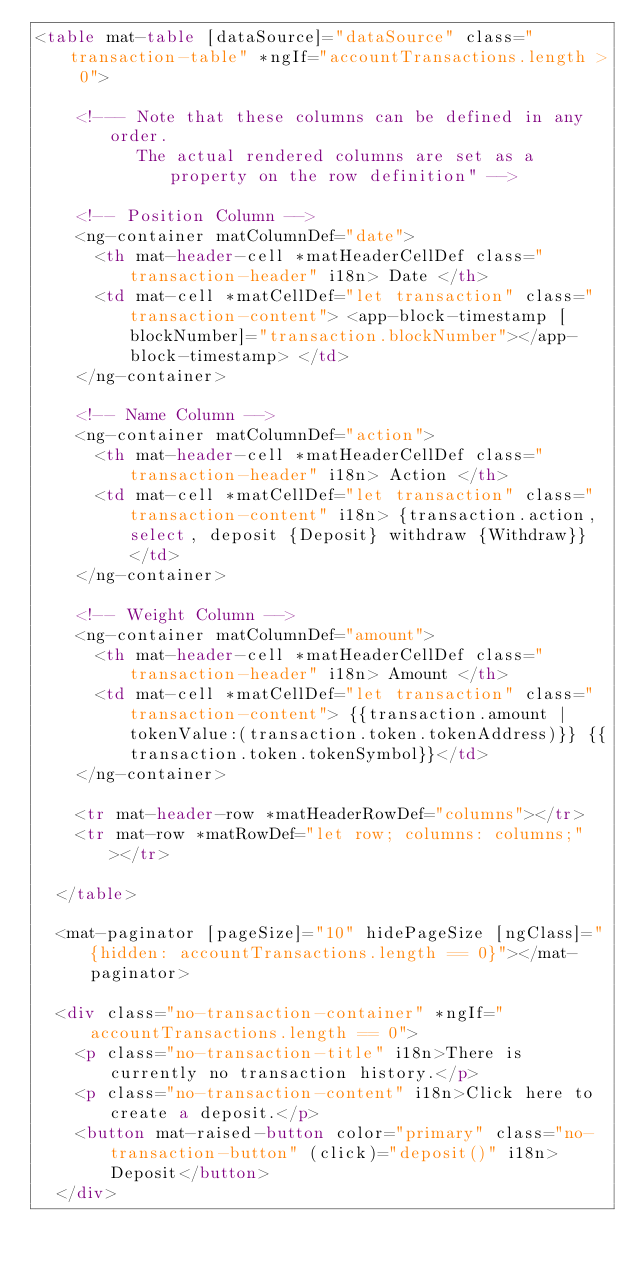<code> <loc_0><loc_0><loc_500><loc_500><_HTML_><table mat-table [dataSource]="dataSource" class="transaction-table" *ngIf="accountTransactions.length > 0">

    <!--- Note that these columns can be defined in any order.
          The actual rendered columns are set as a property on the row definition" -->
  
    <!-- Position Column -->
    <ng-container matColumnDef="date">
      <th mat-header-cell *matHeaderCellDef class="transaction-header" i18n> Date </th>
      <td mat-cell *matCellDef="let transaction" class="transaction-content"> <app-block-timestamp [blockNumber]="transaction.blockNumber"></app-block-timestamp> </td>
    </ng-container>
  
    <!-- Name Column -->
    <ng-container matColumnDef="action">
      <th mat-header-cell *matHeaderCellDef class="transaction-header" i18n> Action </th>
      <td mat-cell *matCellDef="let transaction" class="transaction-content" i18n> {transaction.action, select, deposit {Deposit} withdraw {Withdraw}} </td>
    </ng-container>
  
    <!-- Weight Column -->
    <ng-container matColumnDef="amount">
      <th mat-header-cell *matHeaderCellDef class="transaction-header" i18n> Amount </th>
      <td mat-cell *matCellDef="let transaction" class="transaction-content"> {{transaction.amount | tokenValue:(transaction.token.tokenAddress)}} {{transaction.token.tokenSymbol}}</td>
    </ng-container>
  
    <tr mat-header-row *matHeaderRowDef="columns"></tr>
    <tr mat-row *matRowDef="let row; columns: columns;"></tr>

  </table>

  <mat-paginator [pageSize]="10" hidePageSize [ngClass]="{hidden: accountTransactions.length == 0}"></mat-paginator>

  <div class="no-transaction-container" *ngIf="accountTransactions.length == 0">
    <p class="no-transaction-title" i18n>There is currently no transaction history.</p>
    <p class="no-transaction-content" i18n>Click here to create a deposit.</p>
    <button mat-raised-button color="primary" class="no-transaction-button" (click)="deposit()" i18n>Deposit</button>
  </div></code> 